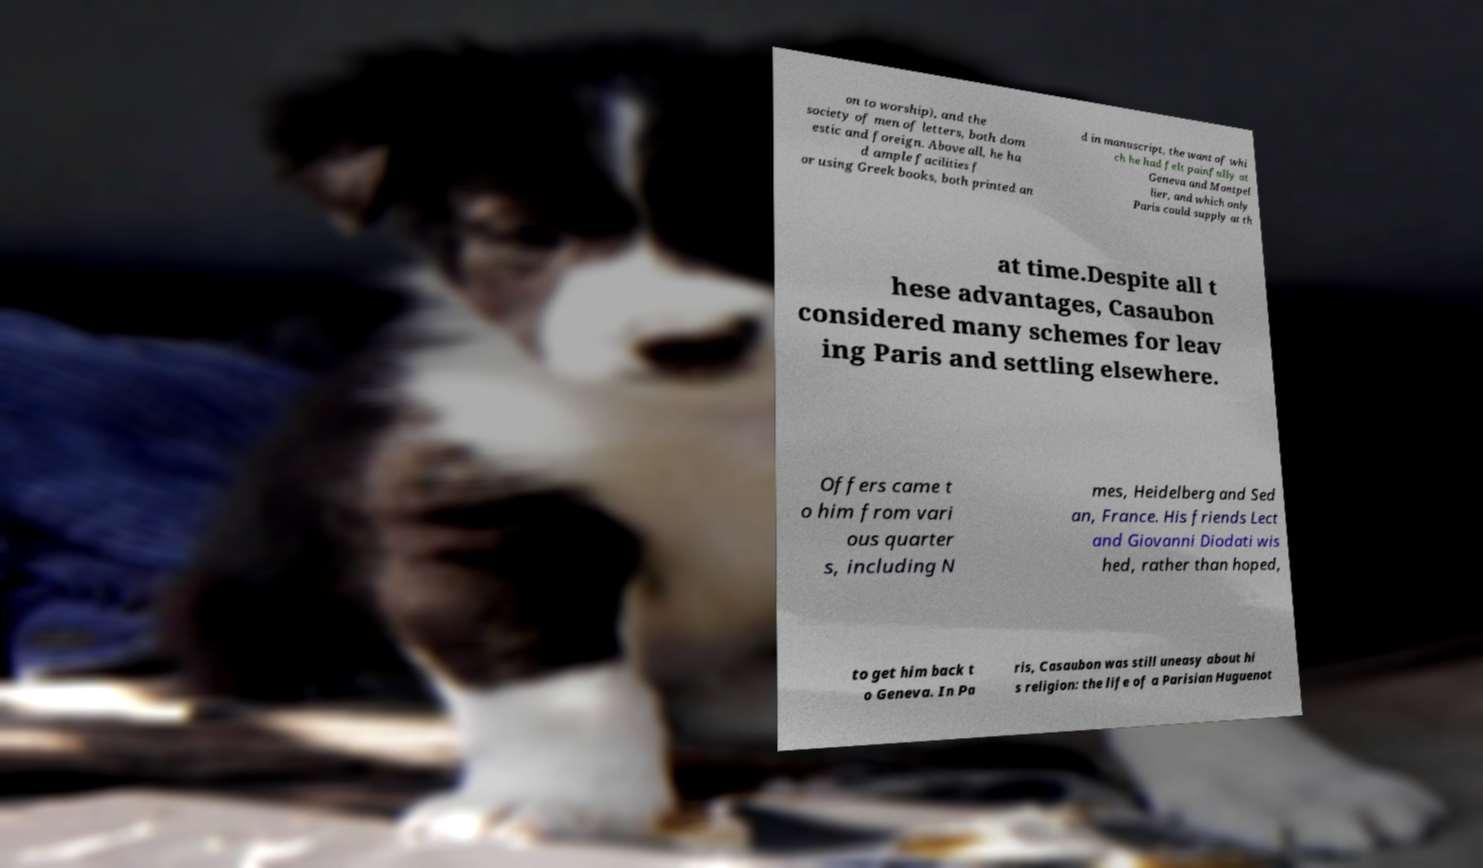I need the written content from this picture converted into text. Can you do that? on to worship), and the society of men of letters, both dom estic and foreign. Above all, he ha d ample facilities f or using Greek books, both printed an d in manuscript, the want of whi ch he had felt painfully at Geneva and Montpel lier, and which only Paris could supply at th at time.Despite all t hese advantages, Casaubon considered many schemes for leav ing Paris and settling elsewhere. Offers came t o him from vari ous quarter s, including N mes, Heidelberg and Sed an, France. His friends Lect and Giovanni Diodati wis hed, rather than hoped, to get him back t o Geneva. In Pa ris, Casaubon was still uneasy about hi s religion: the life of a Parisian Huguenot 